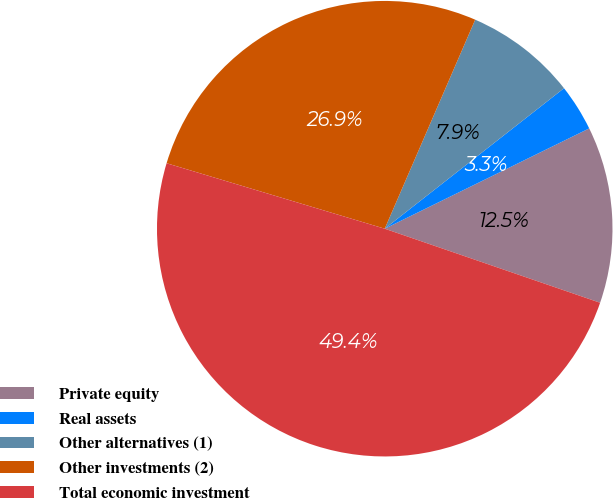<chart> <loc_0><loc_0><loc_500><loc_500><pie_chart><fcel>Private equity<fcel>Real assets<fcel>Other alternatives (1)<fcel>Other investments (2)<fcel>Total economic investment<nl><fcel>12.53%<fcel>3.32%<fcel>7.92%<fcel>26.86%<fcel>49.37%<nl></chart> 